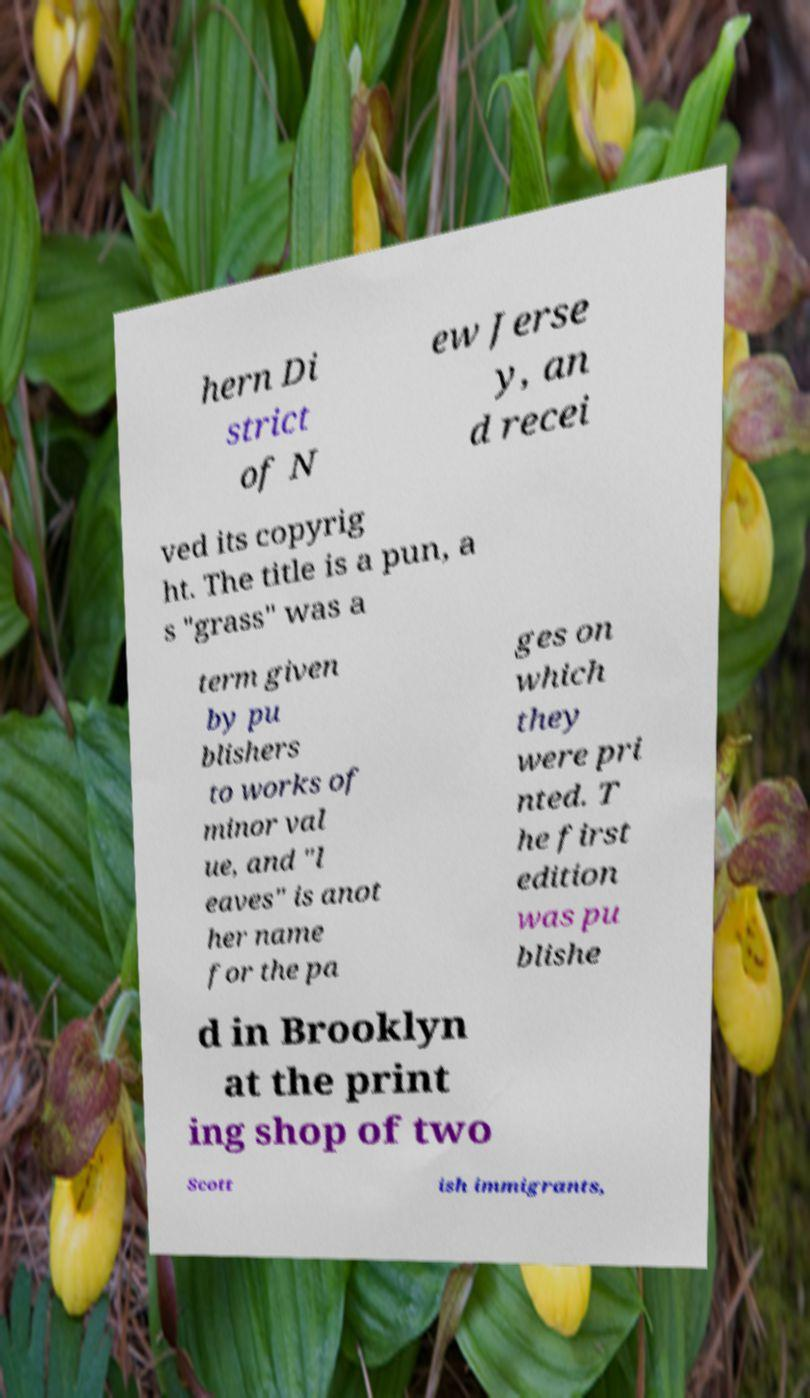There's text embedded in this image that I need extracted. Can you transcribe it verbatim? hern Di strict of N ew Jerse y, an d recei ved its copyrig ht. The title is a pun, a s "grass" was a term given by pu blishers to works of minor val ue, and "l eaves" is anot her name for the pa ges on which they were pri nted. T he first edition was pu blishe d in Brooklyn at the print ing shop of two Scott ish immigrants, 